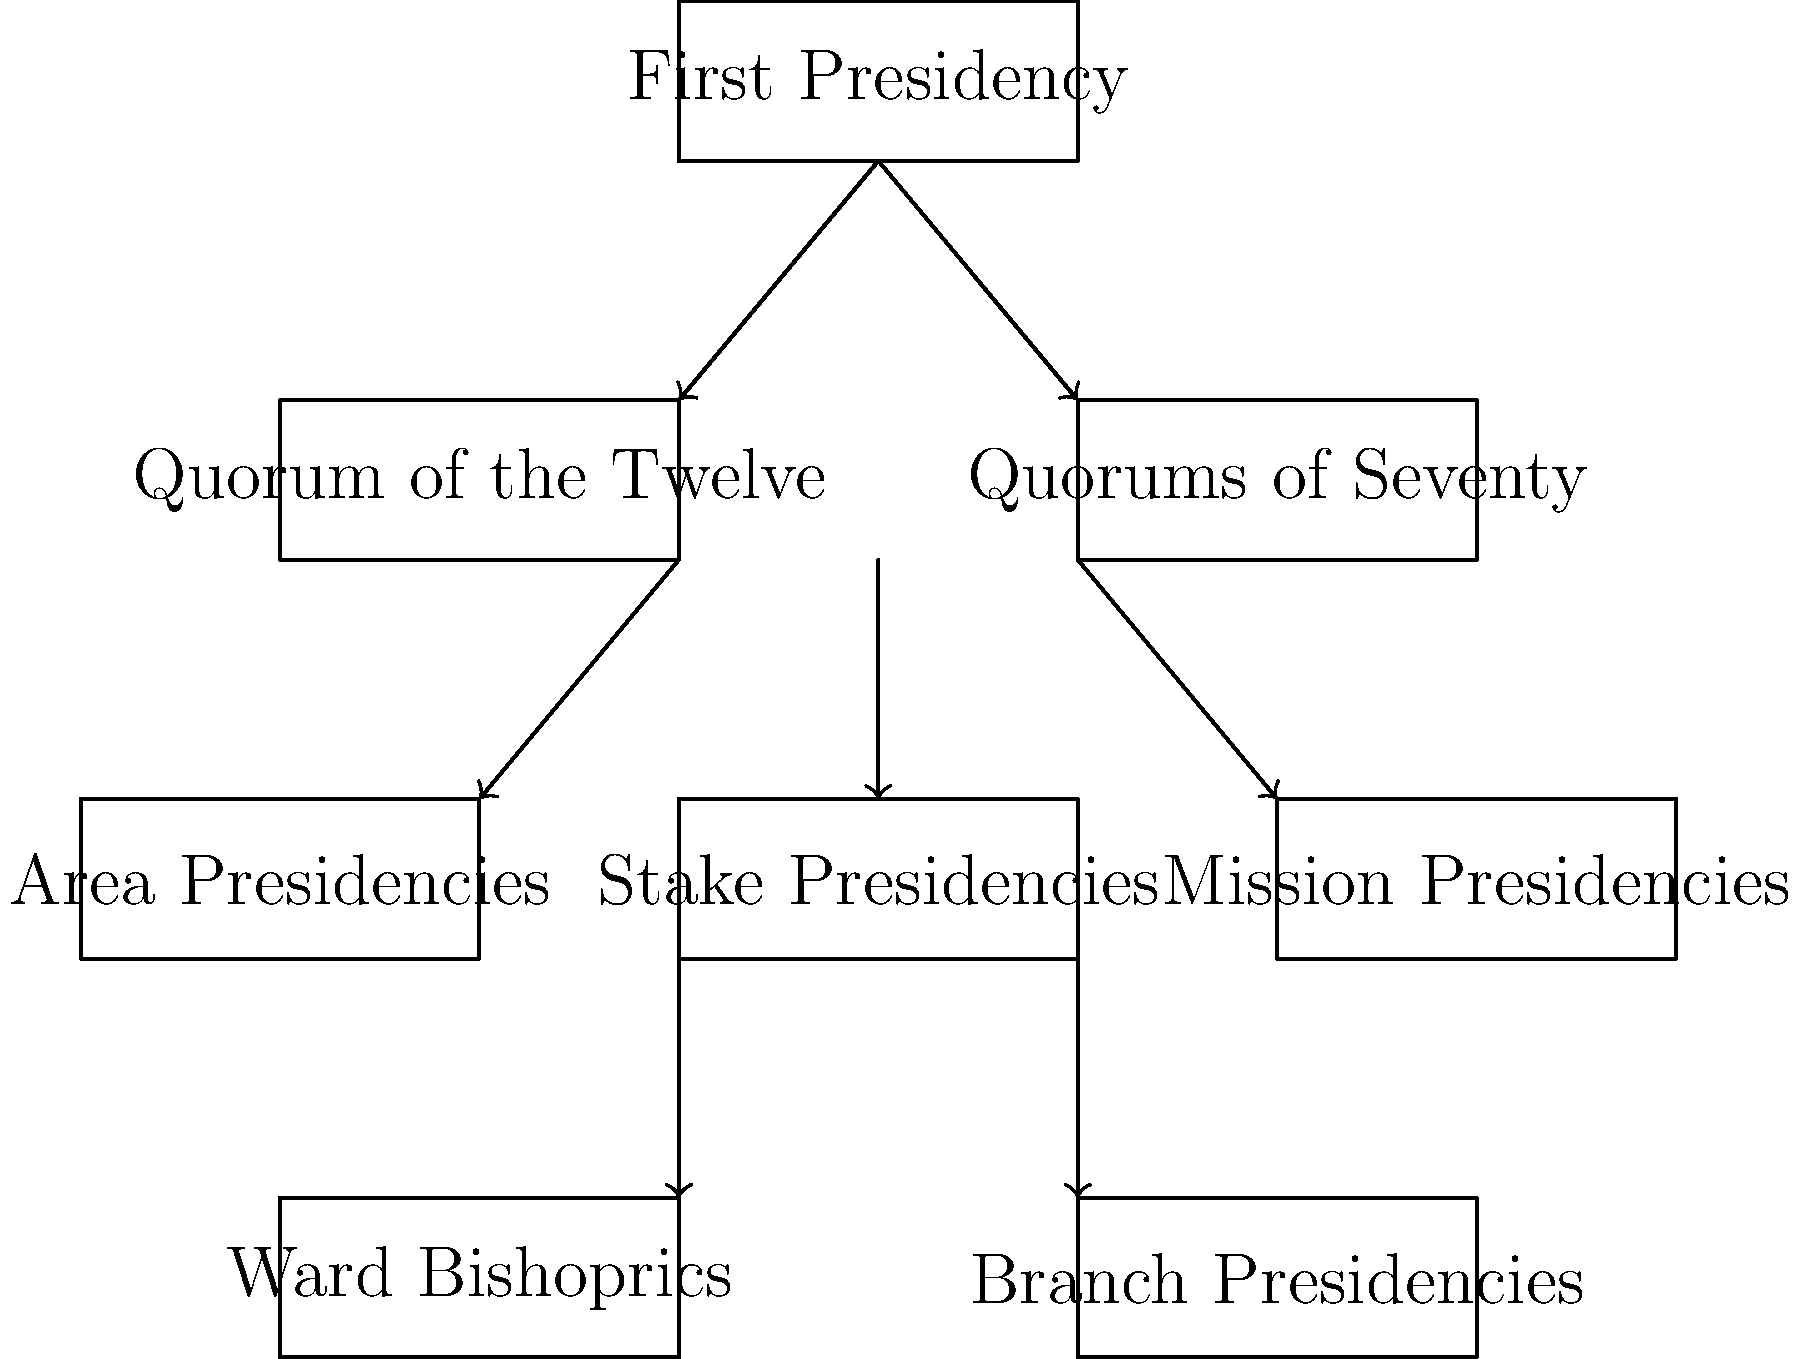In the hierarchical structure of the Mormon church, which leadership body directly oversees both Stake Presidencies and Mission Presidencies? To answer this question, let's examine the organizational chart step-by-step:

1. At the top of the hierarchy is the First Presidency.

2. Directly below the First Presidency, we see two leadership bodies:
   a) The Quorum of the Twelve
   b) Quorums of Seventy

3. Below these two bodies, we find three leadership groups:
   a) Area Presidencies
   b) Stake Presidencies
   c) Mission Presidencies

4. The key to answering this question is identifying which of the higher leadership bodies has direct lines of authority to both Stake Presidencies and Mission Presidencies.

5. Looking at the chart, we can see that the arrows connecting to both Stake Presidencies and Mission Presidencies originate from the Quorums of Seventy.

6. This indicates that the Quorums of Seventy have direct oversight over both Stake Presidencies and Mission Presidencies in the Mormon church hierarchy.

Therefore, the leadership body that directly oversees both Stake Presidencies and Mission Presidencies is the Quorums of Seventy.
Answer: Quorums of Seventy 